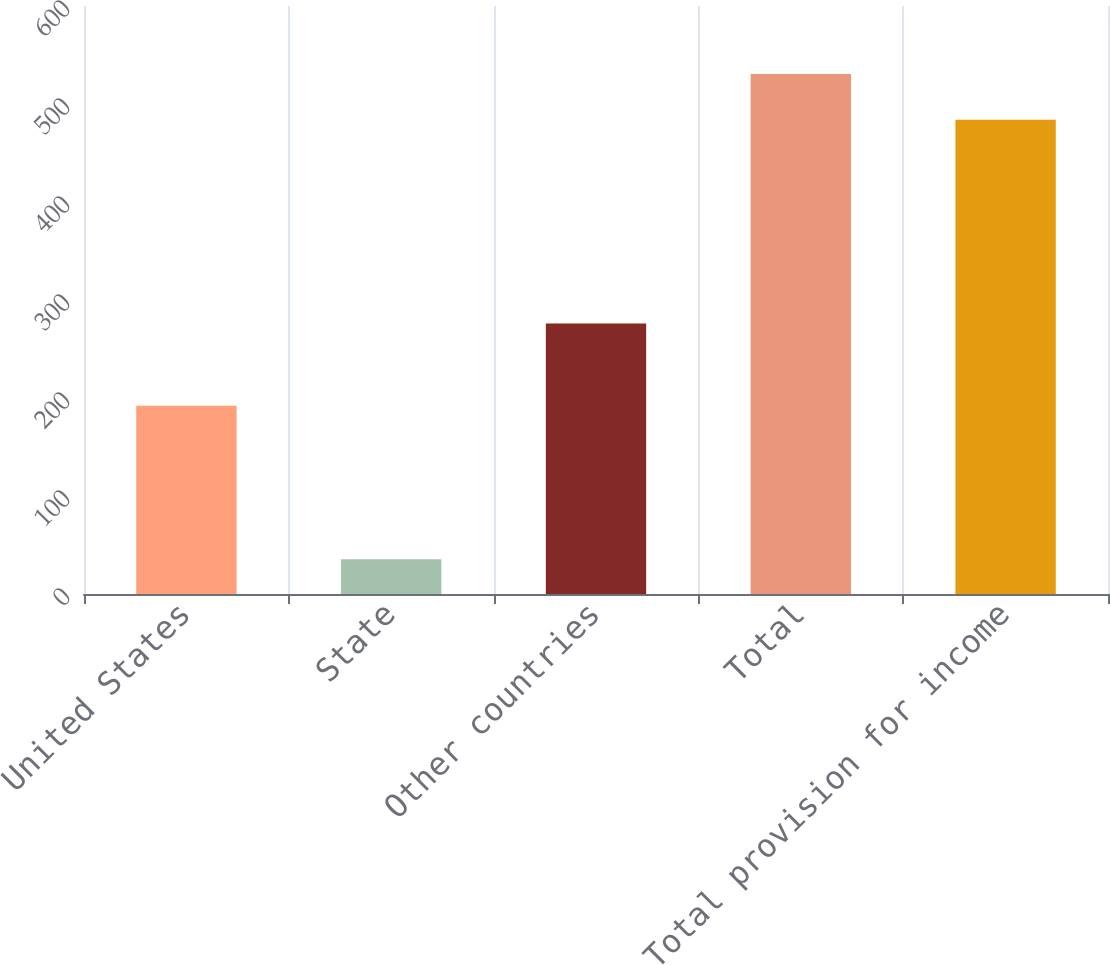Convert chart to OTSL. <chart><loc_0><loc_0><loc_500><loc_500><bar_chart><fcel>United States<fcel>State<fcel>Other countries<fcel>Total<fcel>Total provision for income<nl><fcel>192<fcel>35.4<fcel>275.9<fcel>530.69<fcel>483.9<nl></chart> 